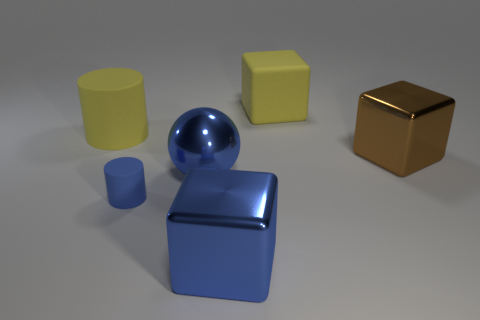Subtract all spheres. How many objects are left? 5 Add 4 tiny green shiny blocks. How many objects exist? 10 Add 3 large yellow blocks. How many large yellow blocks are left? 4 Add 2 small brown metallic cylinders. How many small brown metallic cylinders exist? 2 Subtract 1 brown blocks. How many objects are left? 5 Subtract all large blue objects. Subtract all blue cylinders. How many objects are left? 3 